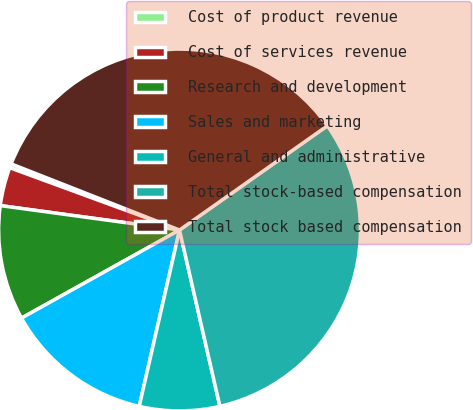Convert chart to OTSL. <chart><loc_0><loc_0><loc_500><loc_500><pie_chart><fcel>Cost of product revenue<fcel>Cost of services revenue<fcel>Research and development<fcel>Sales and marketing<fcel>General and administrative<fcel>Total stock-based compensation<fcel>Total stock based compensation<nl><fcel>0.36%<fcel>3.44%<fcel>10.25%<fcel>13.33%<fcel>7.16%<fcel>31.19%<fcel>34.27%<nl></chart> 